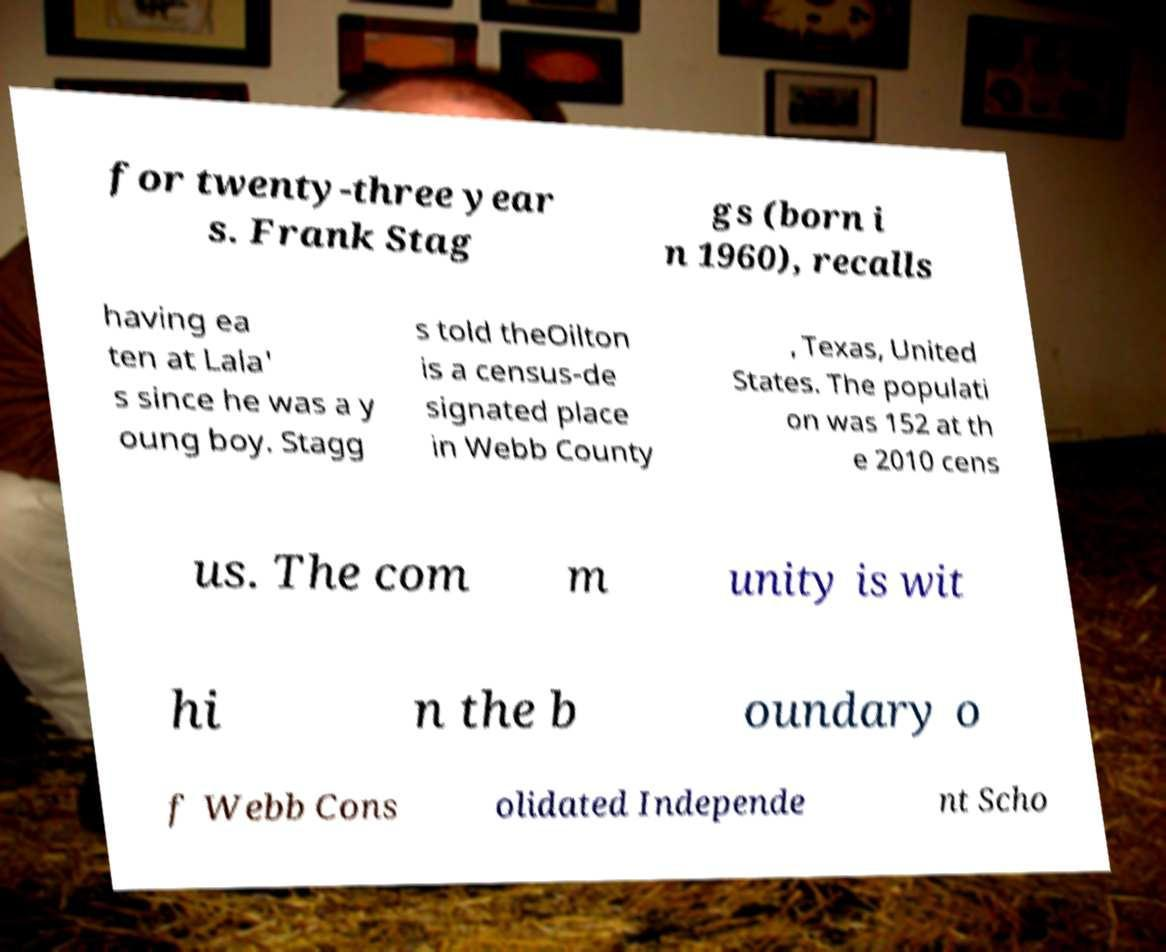I need the written content from this picture converted into text. Can you do that? for twenty-three year s. Frank Stag gs (born i n 1960), recalls having ea ten at Lala' s since he was a y oung boy. Stagg s told theOilton is a census-de signated place in Webb County , Texas, United States. The populati on was 152 at th e 2010 cens us. The com m unity is wit hi n the b oundary o f Webb Cons olidated Independe nt Scho 